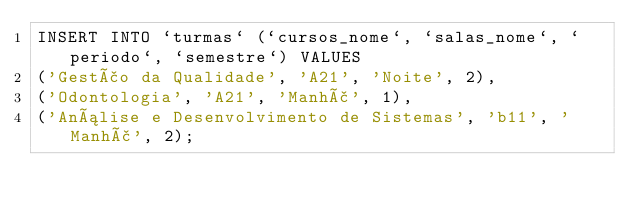Convert code to text. <code><loc_0><loc_0><loc_500><loc_500><_SQL_>INSERT INTO `turmas` (`cursos_nome`, `salas_nome`, `periodo`, `semestre`) VALUES
('Gestão da Qualidade', 'A21', 'Noite', 2),
('Odontologia', 'A21', 'Manhã', 1),
('Análise e Desenvolvimento de Sistemas', 'b11', 'Manhã', 2);

</code> 